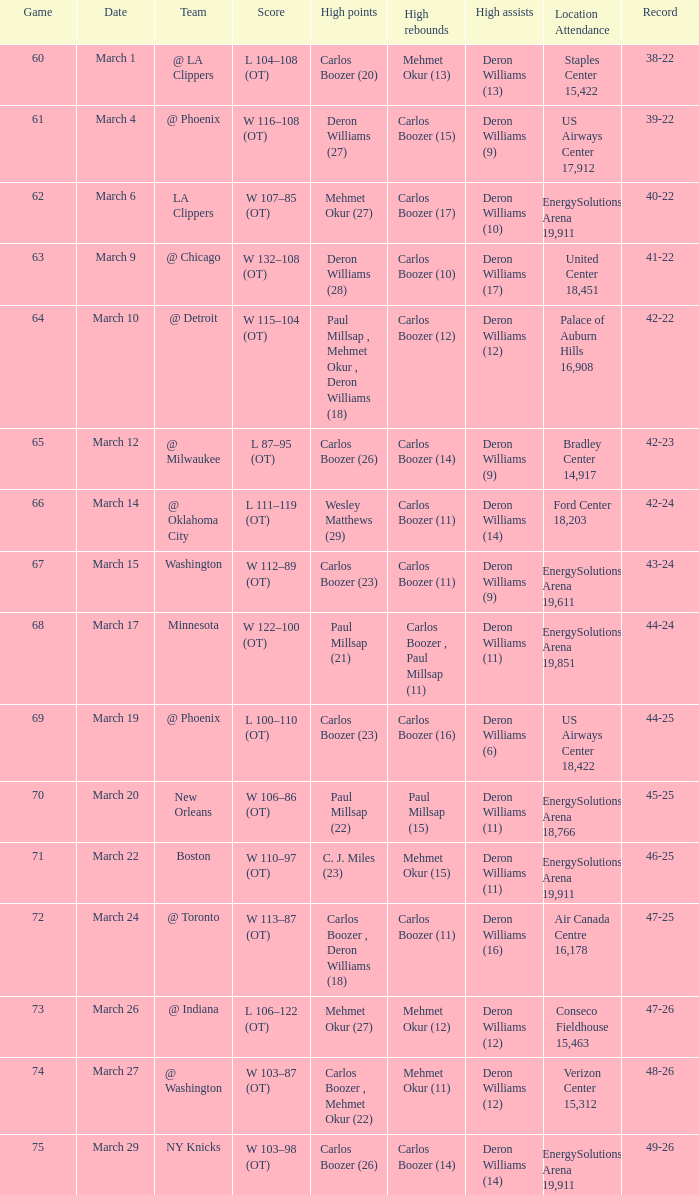What was the record at the game where Deron Williams (6) did the high assists? 44-25. 